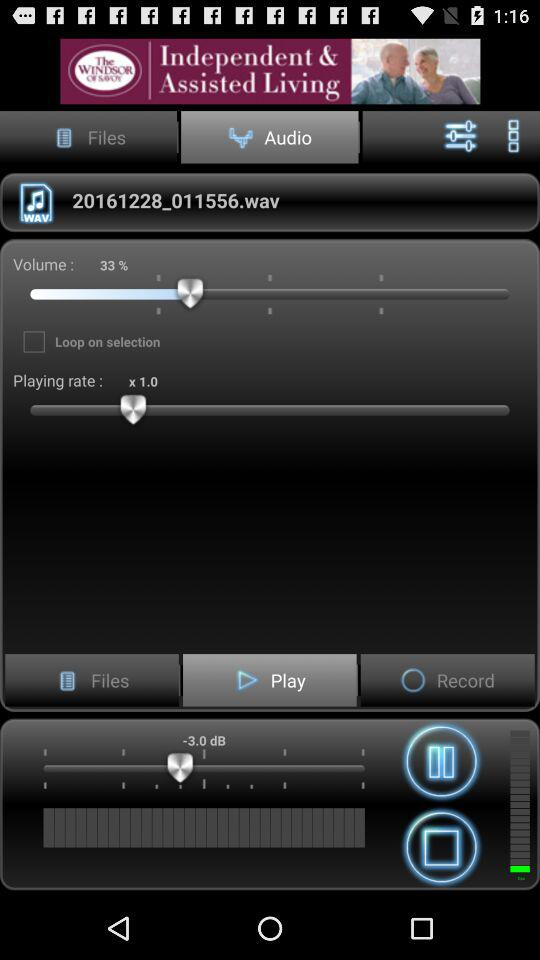What is the status of the "Loop on selection"? The status of the "Loop on selection" is "off". 